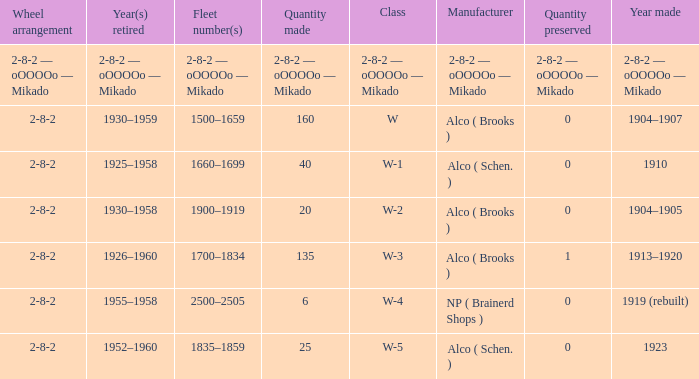What is the quantity preserved to the locomotive with a quantity made of 6? 0.0. 